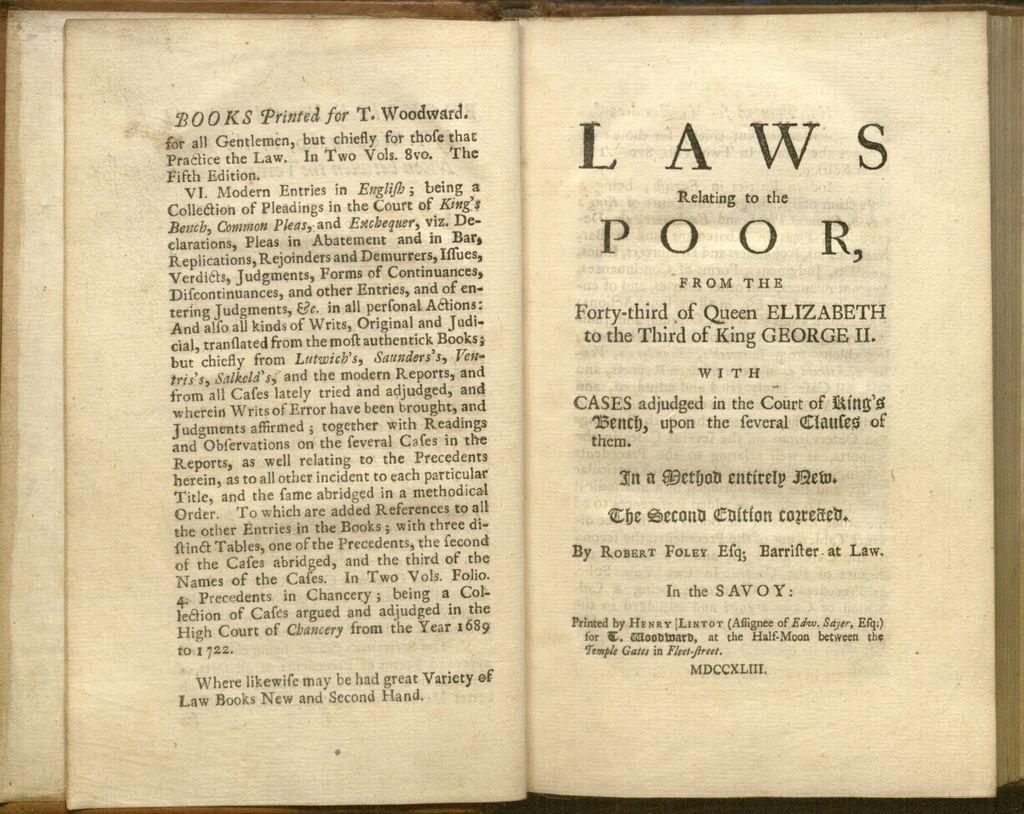What is the first world on the right page?
Keep it short and to the point. Laws. Laws relating to the what?
Give a very brief answer. Poor. 